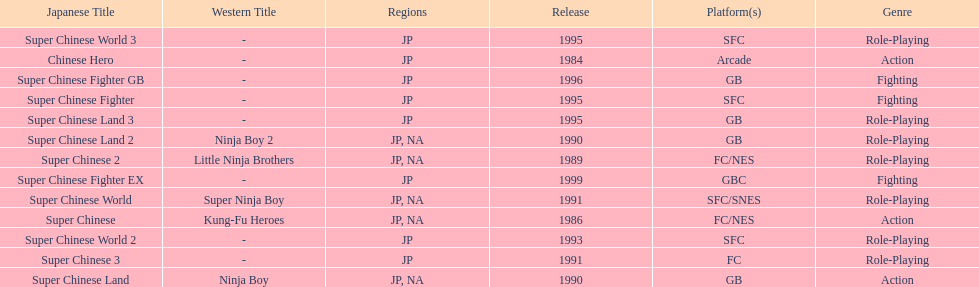The first year a game was released in north america 1986. 